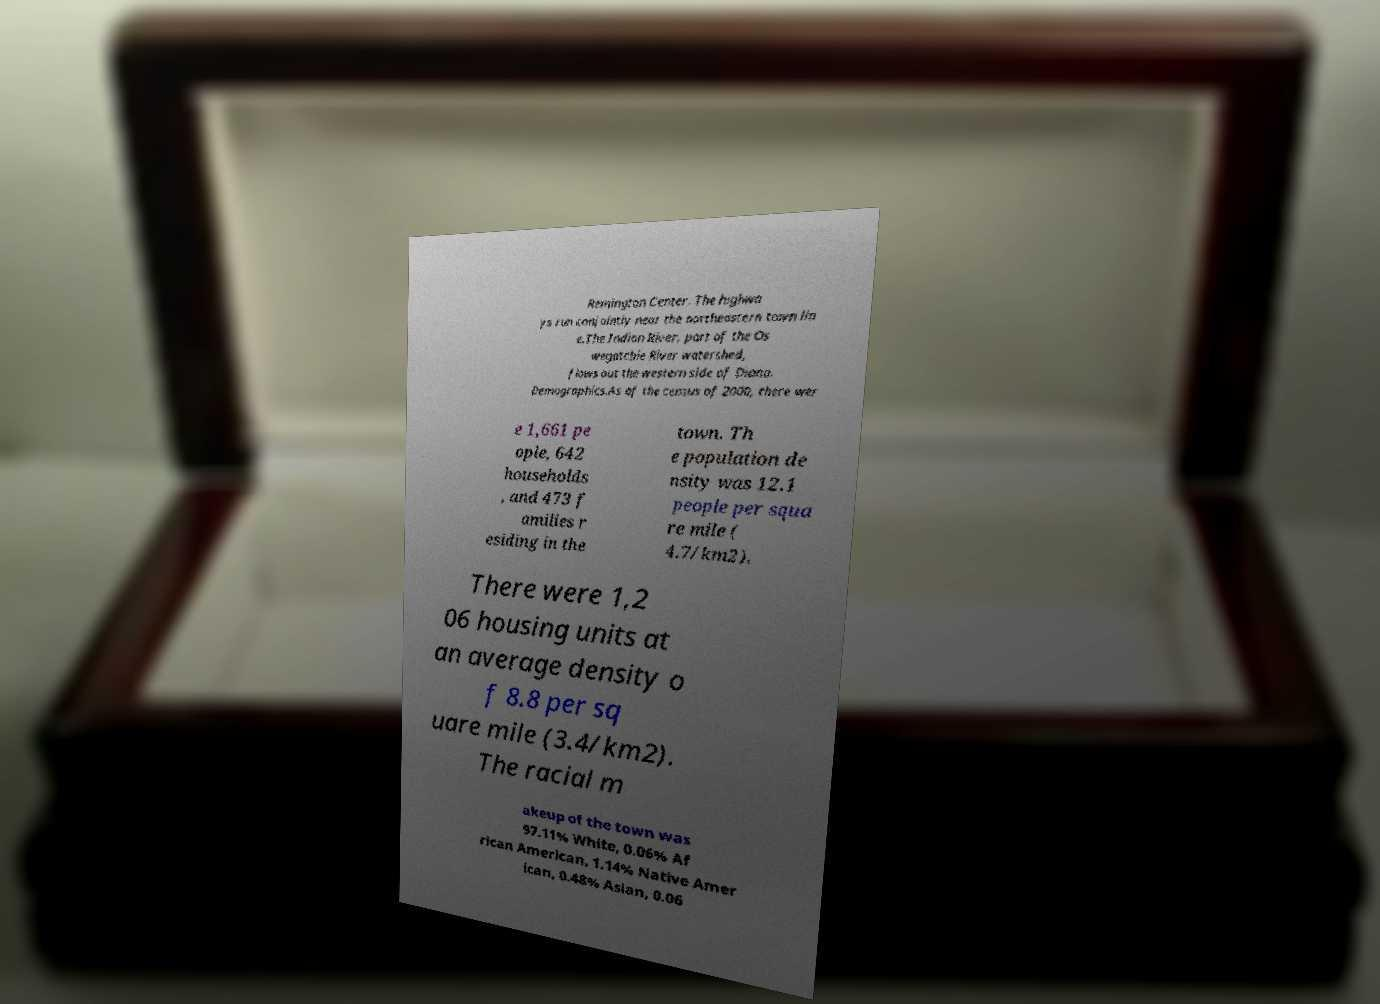Could you extract and type out the text from this image? Remington Center. The highwa ys run conjointly near the northeastern town lin e.The Indian River, part of the Os wegatchie River watershed, flows out the western side of Diana. Demographics.As of the census of 2000, there wer e 1,661 pe ople, 642 households , and 473 f amilies r esiding in the town. Th e population de nsity was 12.1 people per squa re mile ( 4.7/km2). There were 1,2 06 housing units at an average density o f 8.8 per sq uare mile (3.4/km2). The racial m akeup of the town was 97.11% White, 0.06% Af rican American, 1.14% Native Amer ican, 0.48% Asian, 0.06 